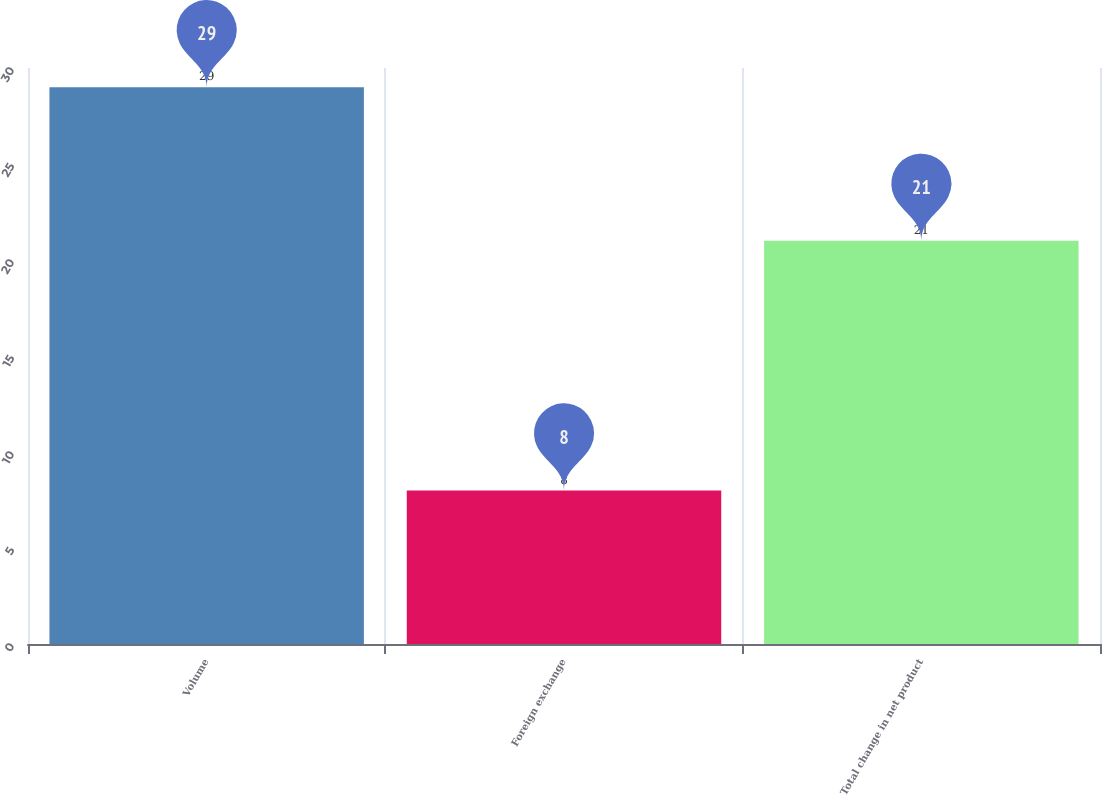<chart> <loc_0><loc_0><loc_500><loc_500><bar_chart><fcel>Volume<fcel>Foreign exchange<fcel>Total change in net product<nl><fcel>29<fcel>8<fcel>21<nl></chart> 